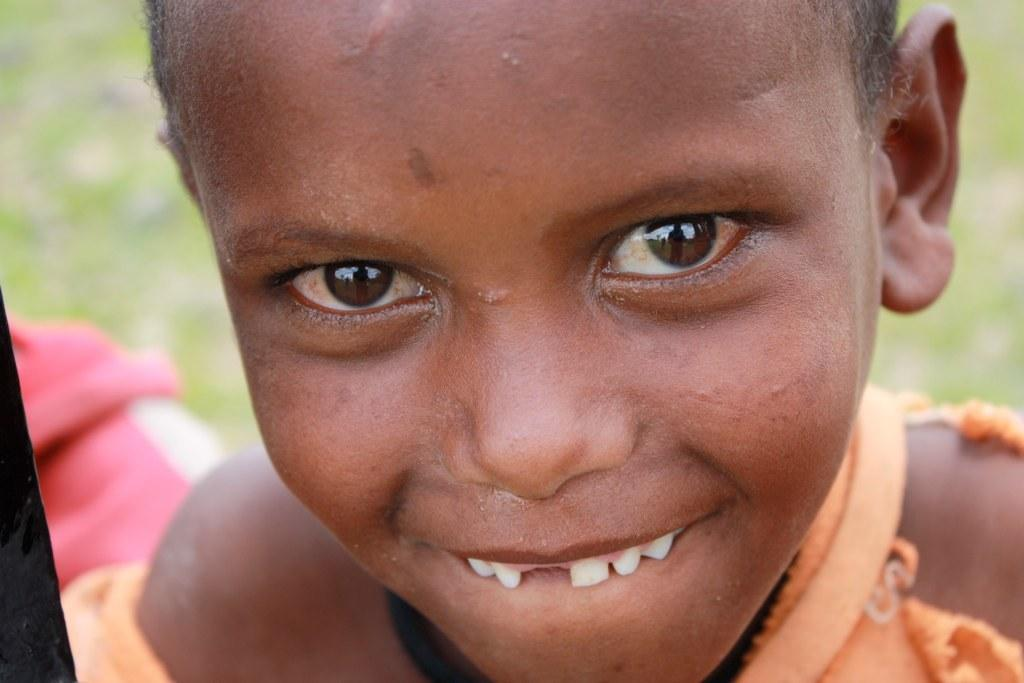What is the main subject in the foreground of the image? There is a kid in the foreground of the image. What is the expression on the kid's face? The kid is smiling. What color is the background of the image? The background of the image is green in color. What type of suit is the kid wearing in the image? There is no suit visible in the image; the kid is not wearing any clothing mentioned in the facts. 